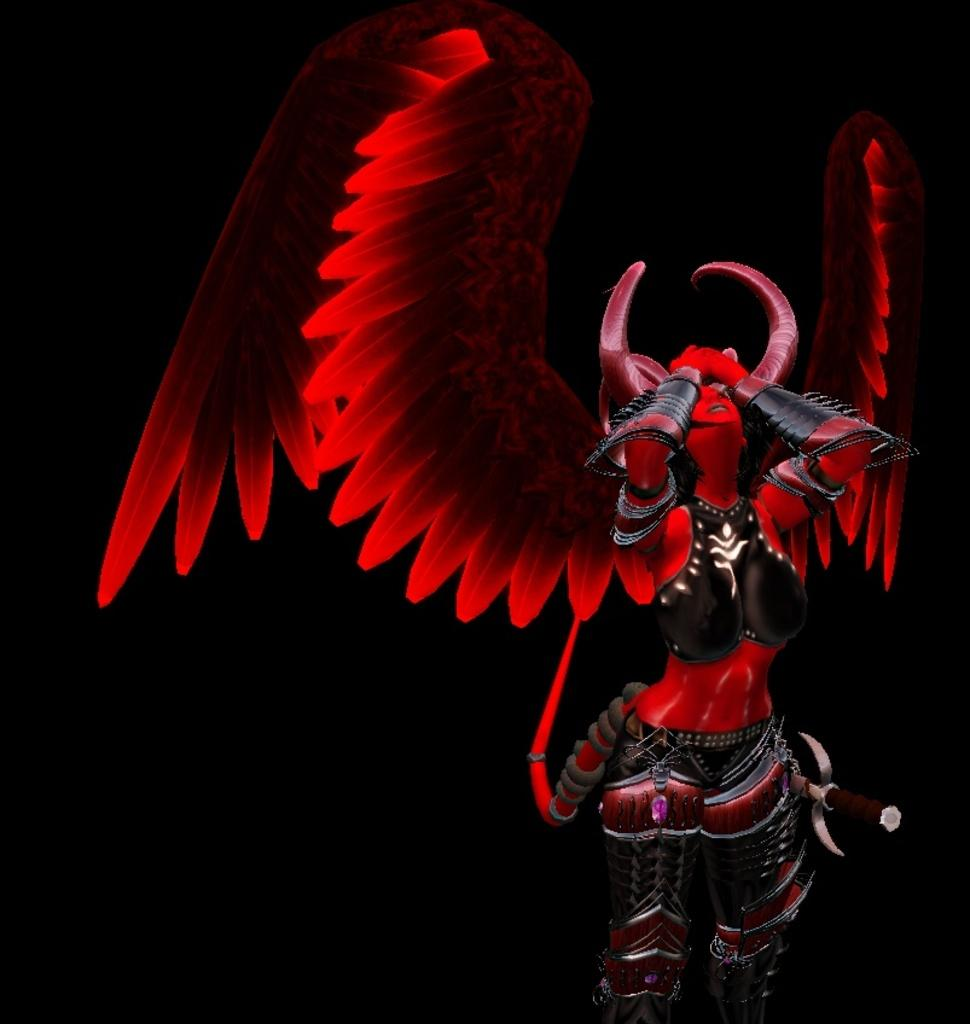What is the main subject in the foreground of the image? There is a woman with wings and horns in the foreground of the image. What color is the woman wearing? The woman is in red color. Can you describe the background of the image? The background of the image is dark. What type of music can be heard in the image? There is no music present in the image, as it is a still image. 